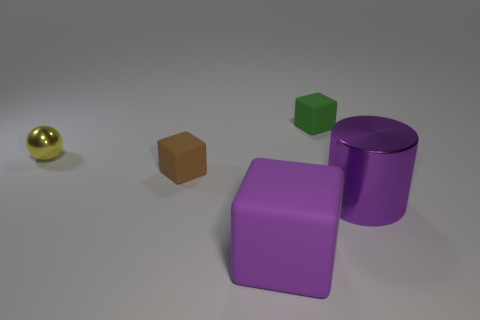How many objects are there in the image, and can you describe them by their shapes and colors? There are four objects in the image. Starting from the left, there's a small, shiny golden sphere, a brown cube, a green cube, and two purple objects: one is a cylinder and the other is a cube. Each object has a distinct matte or shiny finish, and the shapes are simple 3D geometric forms. 